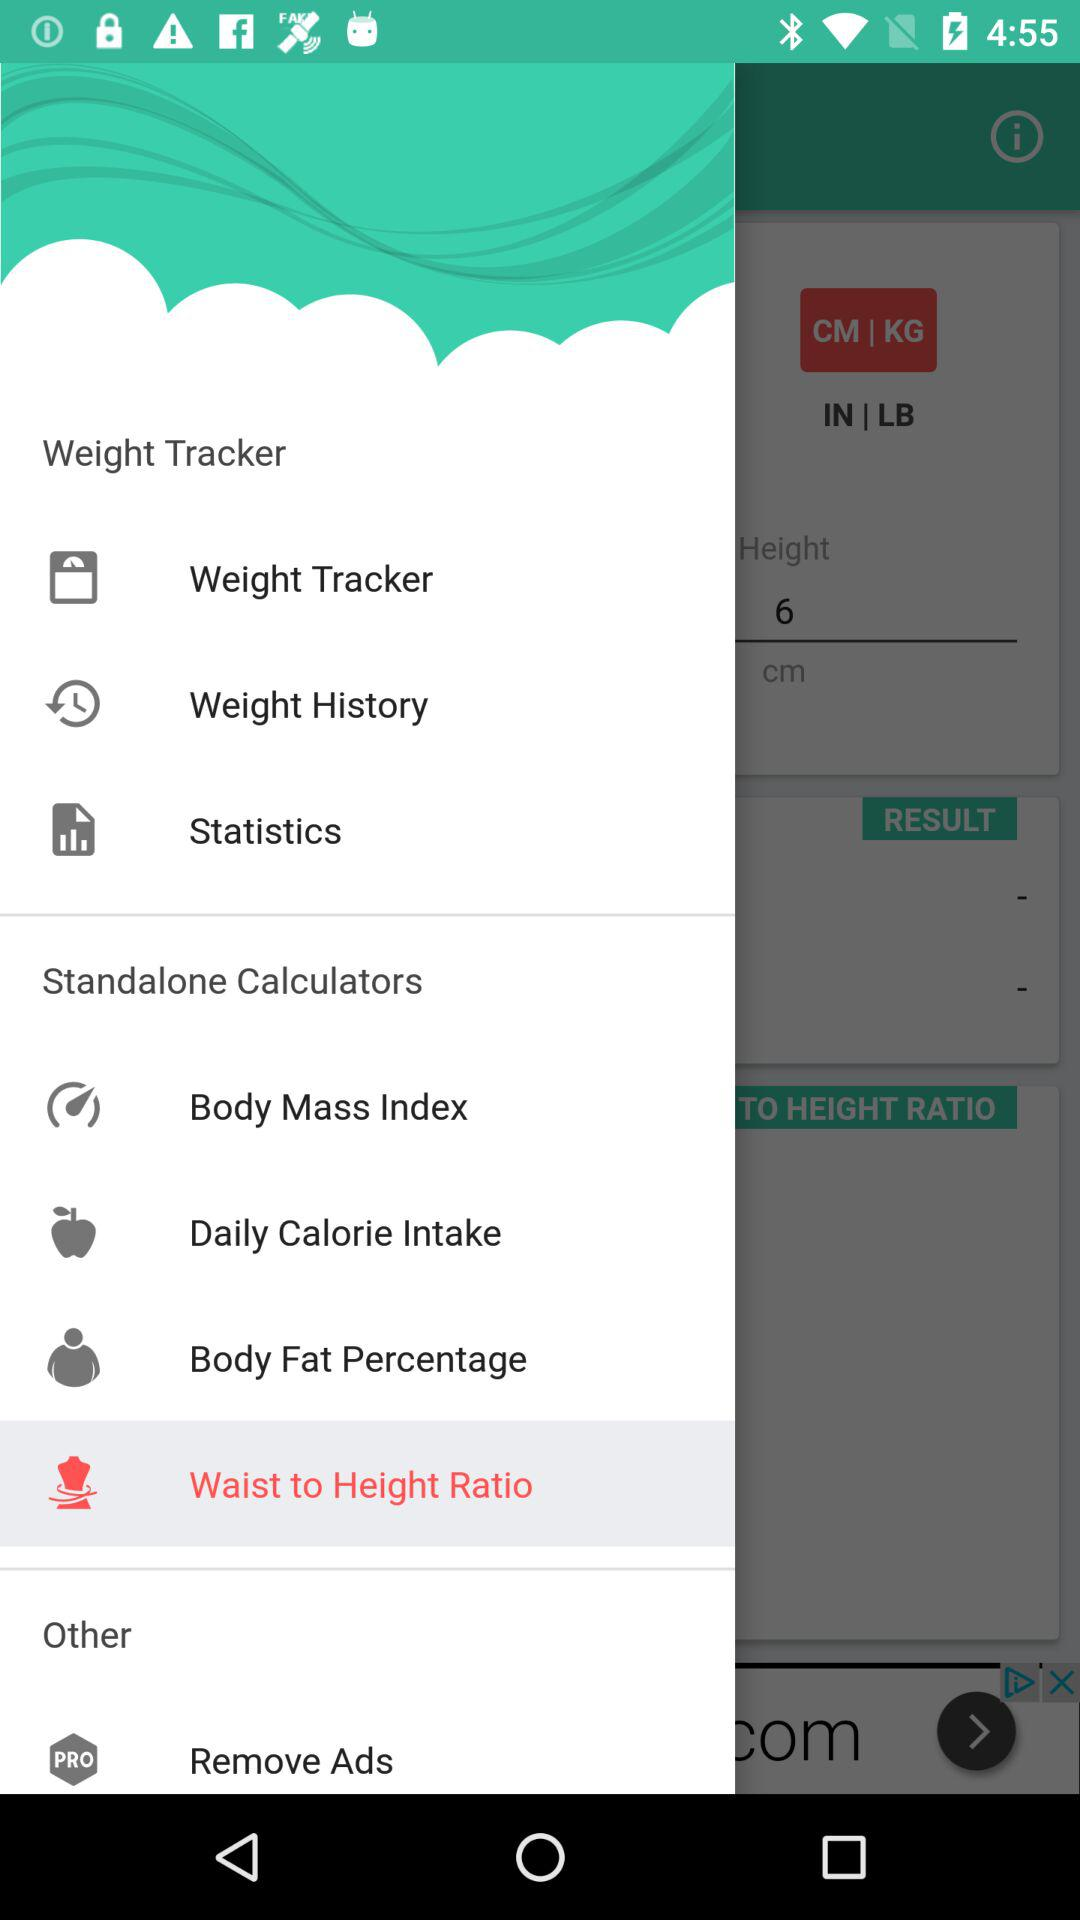Which option is selected in "Standalone Calculators"? The selected option is "Waist to Height Ratio". 